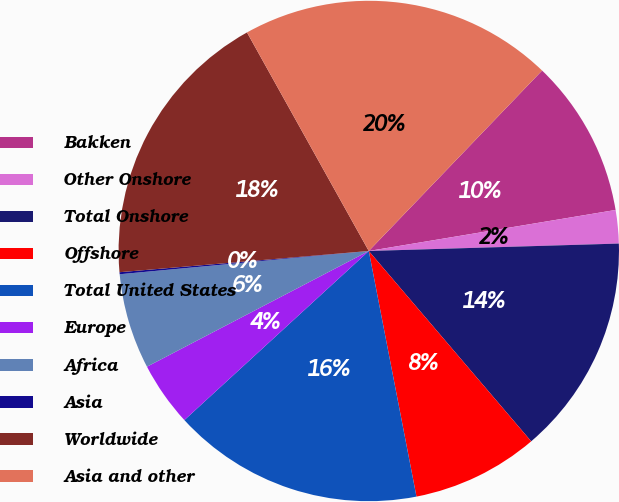Convert chart to OTSL. <chart><loc_0><loc_0><loc_500><loc_500><pie_chart><fcel>Bakken<fcel>Other Onshore<fcel>Total Onshore<fcel>Offshore<fcel>Total United States<fcel>Europe<fcel>Africa<fcel>Asia<fcel>Worldwide<fcel>Asia and other<nl><fcel>10.2%<fcel>2.15%<fcel>14.23%<fcel>8.19%<fcel>16.24%<fcel>4.16%<fcel>6.17%<fcel>0.13%<fcel>18.26%<fcel>20.27%<nl></chart> 